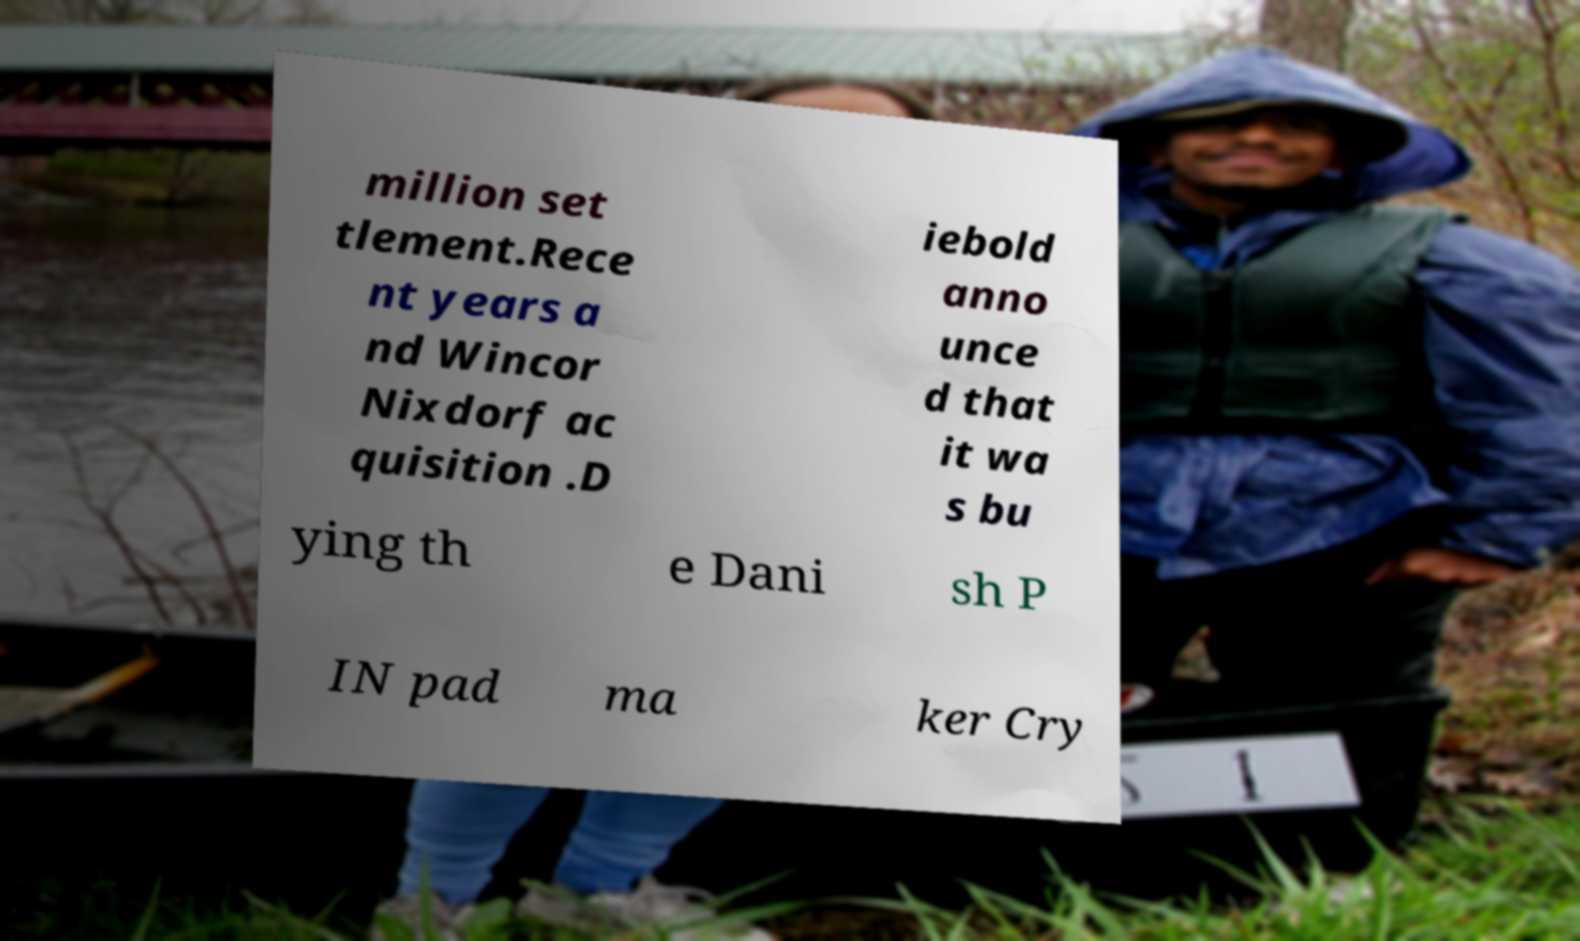Could you assist in decoding the text presented in this image and type it out clearly? million set tlement.Rece nt years a nd Wincor Nixdorf ac quisition .D iebold anno unce d that it wa s bu ying th e Dani sh P IN pad ma ker Cry 